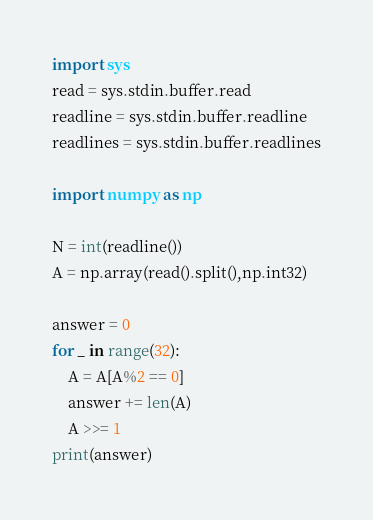Convert code to text. <code><loc_0><loc_0><loc_500><loc_500><_Python_>import sys
read = sys.stdin.buffer.read
readline = sys.stdin.buffer.readline
readlines = sys.stdin.buffer.readlines

import numpy as np

N = int(readline())
A = np.array(read().split(),np.int32)

answer = 0
for _ in range(32):
    A = A[A%2 == 0]
    answer += len(A)
    A >>= 1
print(answer)
</code> 